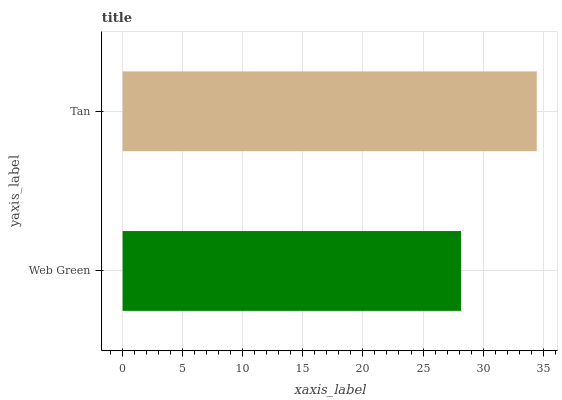Is Web Green the minimum?
Answer yes or no. Yes. Is Tan the maximum?
Answer yes or no. Yes. Is Tan the minimum?
Answer yes or no. No. Is Tan greater than Web Green?
Answer yes or no. Yes. Is Web Green less than Tan?
Answer yes or no. Yes. Is Web Green greater than Tan?
Answer yes or no. No. Is Tan less than Web Green?
Answer yes or no. No. Is Tan the high median?
Answer yes or no. Yes. Is Web Green the low median?
Answer yes or no. Yes. Is Web Green the high median?
Answer yes or no. No. Is Tan the low median?
Answer yes or no. No. 